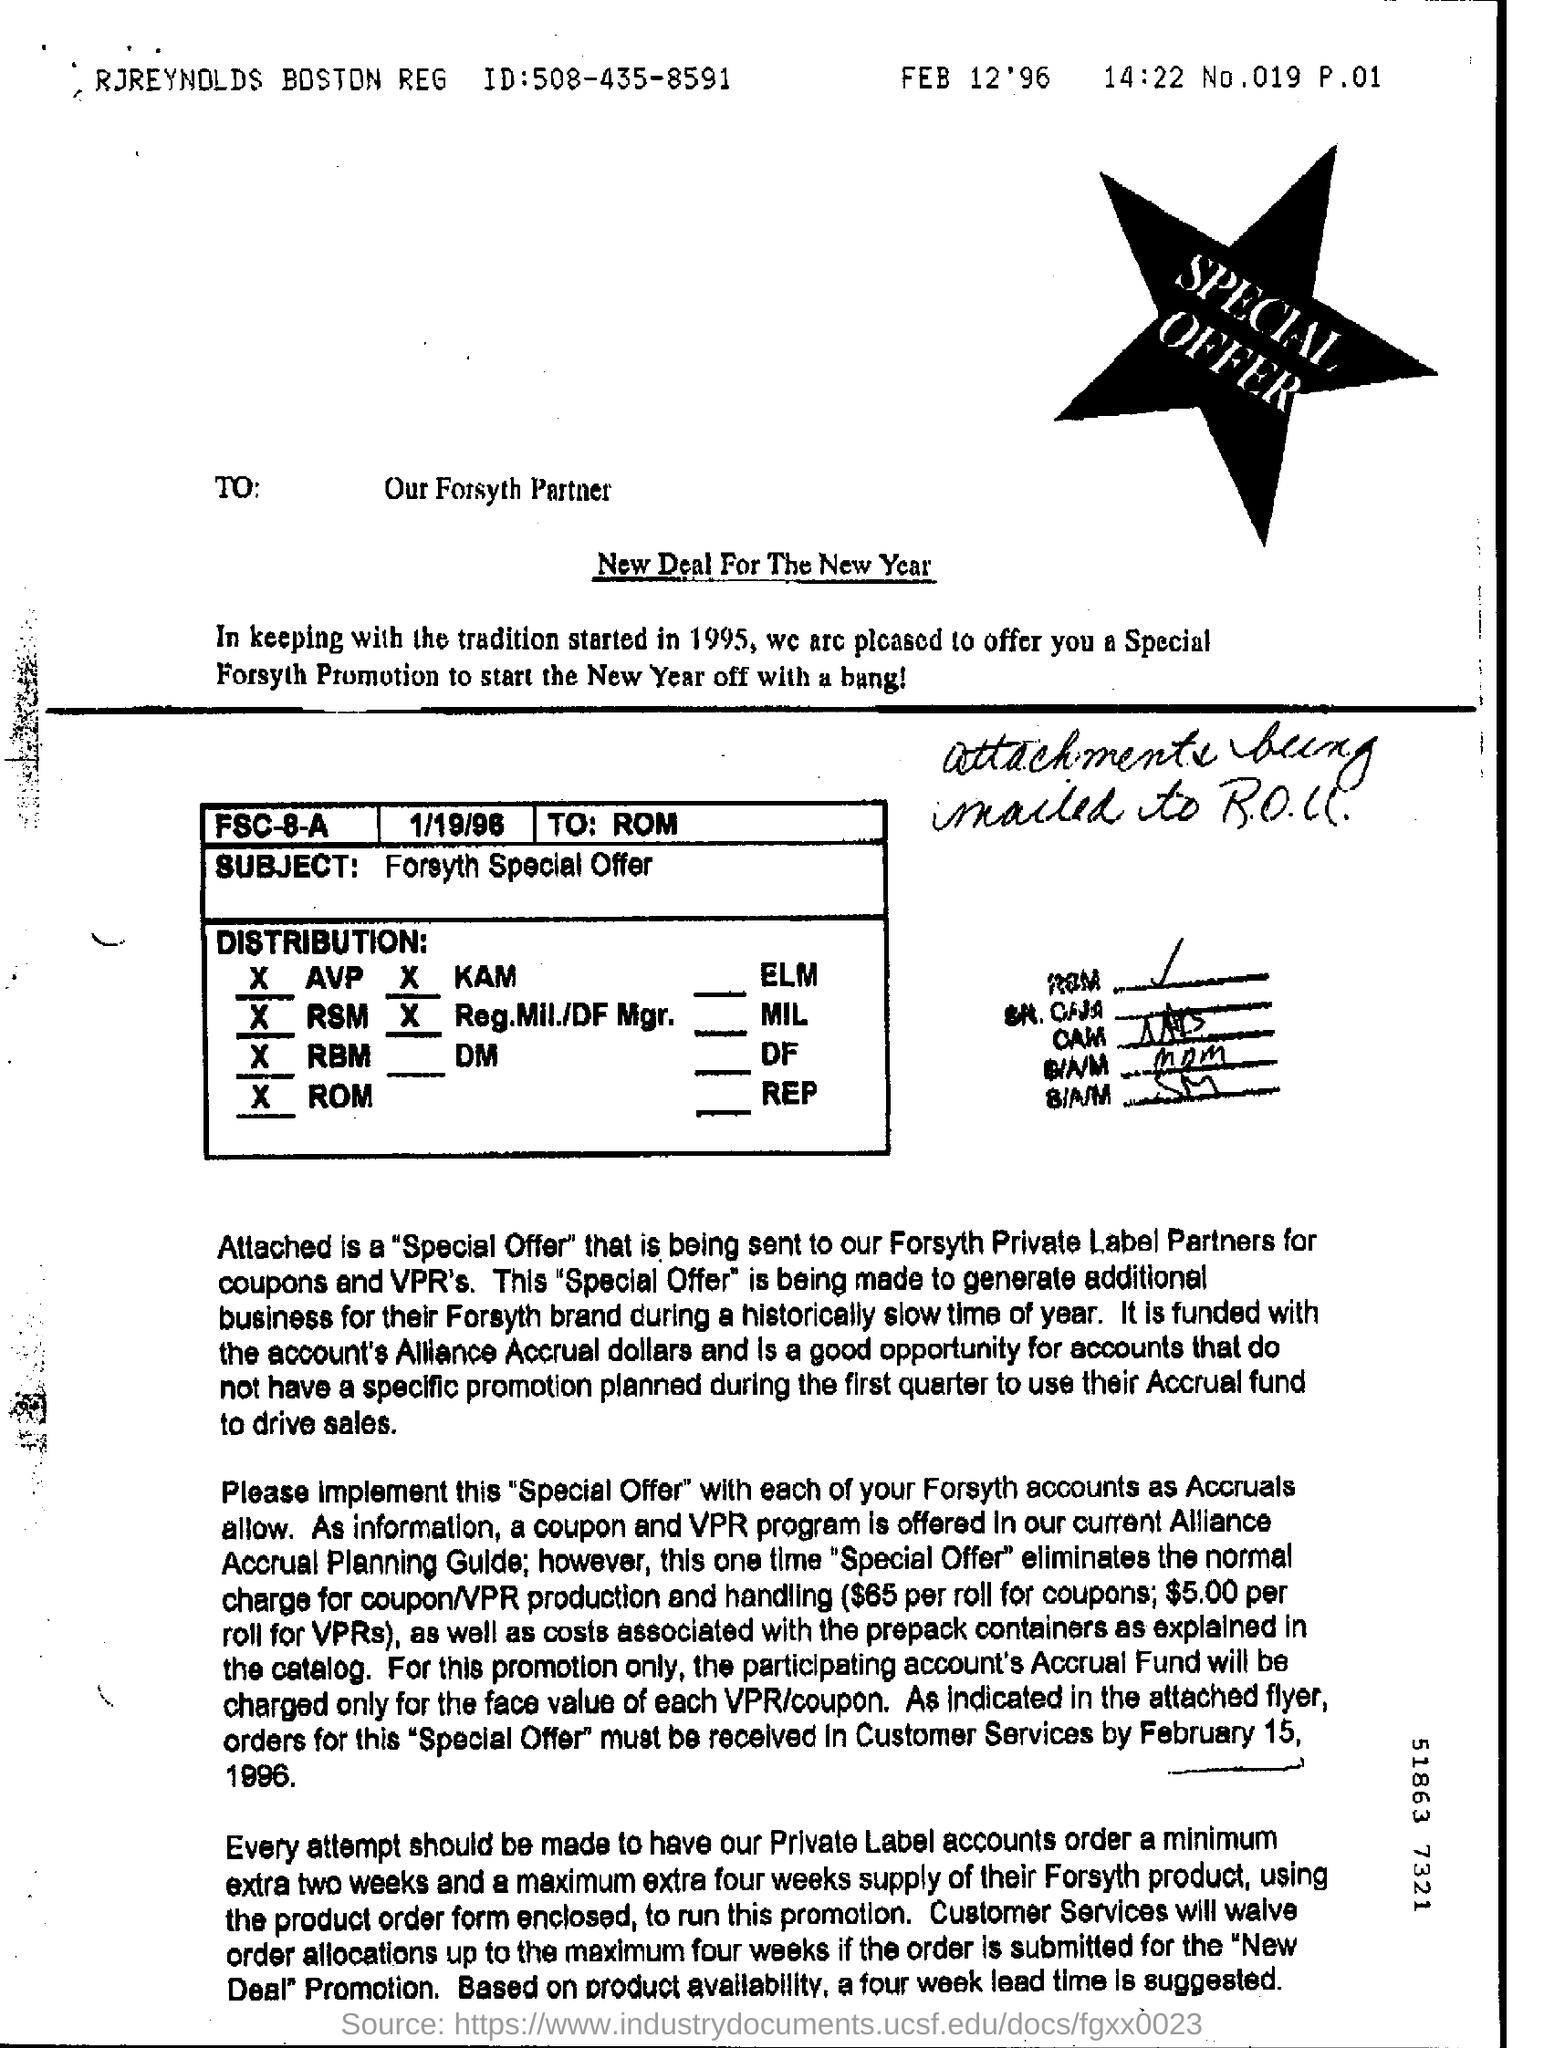To whom is this Document addressed to?
Make the answer very short. Our forsyth partner. 